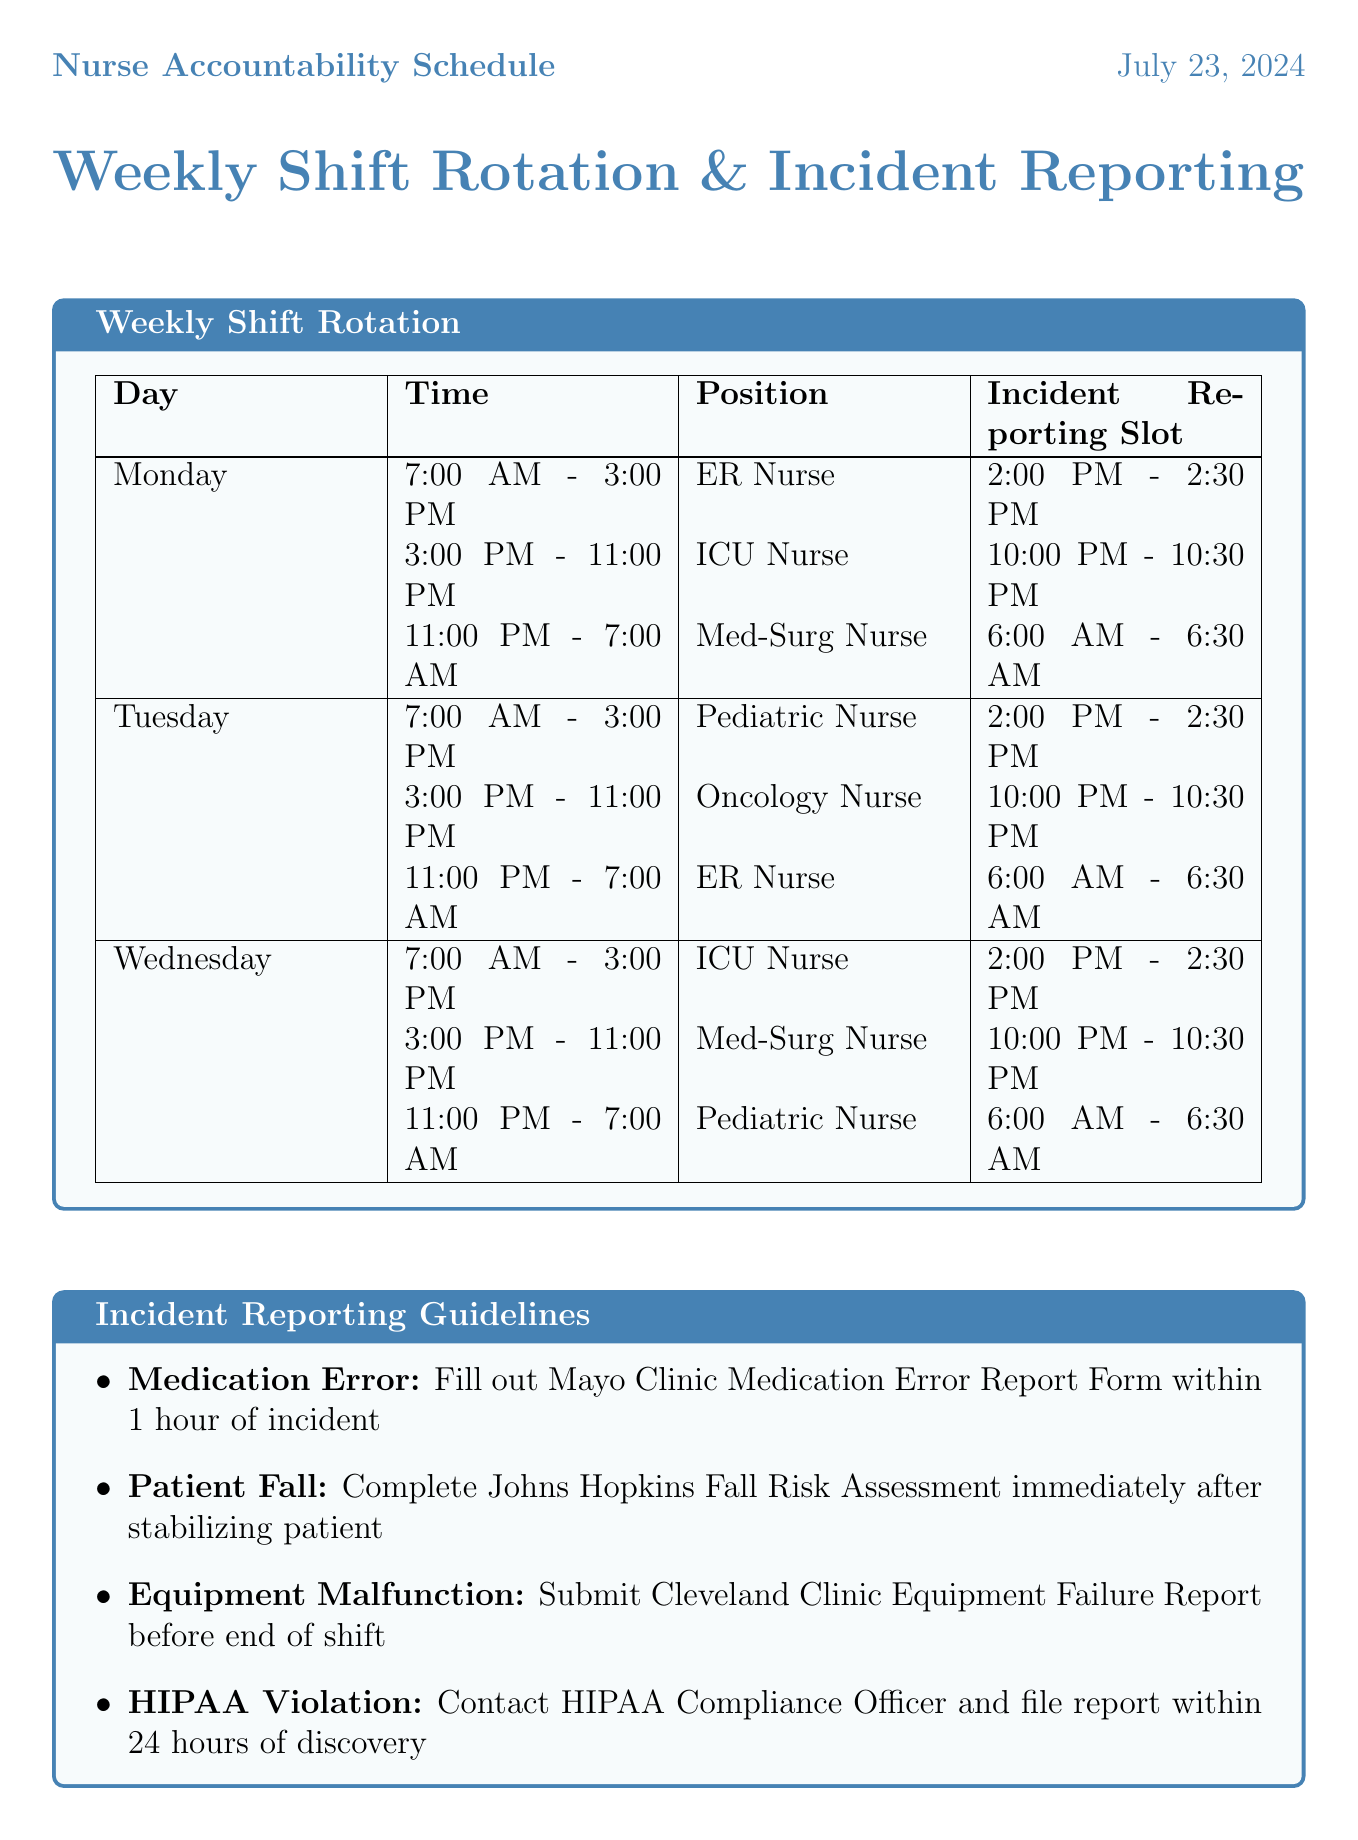What position is scheduled for Monday morning? The schedule lists the position of the nurse working Monday morning from 7:00 AM to 3:00 PM, which is specified as ER Nurse.
Answer: ER Nurse How long is the incident reporting slot for ICU Nurse on Monday? The incident reporting slot for the ICU Nurse working on Monday is from 10:00 PM to 10:30 PM, lasting for 30 minutes.
Answer: 30 minutes When is the incident reporting slot for the Pediatric Nurse on Tuesday? The incident reporting slot for the Pediatric Nurse on Tuesday is scheduled from 2:00 PM to 2:30 PM.
Answer: 2:00 PM - 2:30 PM What is the reporting procedure for a Medication Error? The document outlines the reporting procedure for a Medication Error as filling out the Mayo Clinic Medication Error Report Form.
Answer: Fill out Mayo Clinic Medication Error Report Form What frequency does the Daily Huddle occur? The Daily Huddle is mentioned to occur every shift change, which refers to the frequency of its occurrence.
Answer: Every shift change Which initiative provides training on balancing accountability? The initiative related to balancing accountability is titled Just Culture Training, as described in the document.
Answer: Just Culture Training What type of incident must be reported immediately after stabilizing the patient? According to the guidelines, a Patient Fall must be reported immediately after stabilizing the patient.
Answer: Patient Fall How often are peer reviews conducted? The document states that peer reviews are conducted monthly, which indicates their frequency.
Answer: Monthly What type of survey is completed annually? The Safety Culture Survey is specified to be completed annually as part of the accountability measures described.
Answer: Safety Culture Survey 